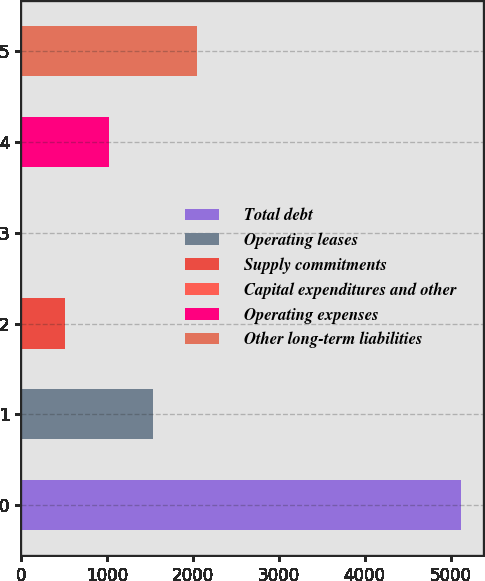Convert chart. <chart><loc_0><loc_0><loc_500><loc_500><bar_chart><fcel>Total debt<fcel>Operating leases<fcel>Supply commitments<fcel>Capital expenditures and other<fcel>Operating expenses<fcel>Other long-term liabilities<nl><fcel>5120<fcel>1536.7<fcel>512.9<fcel>1<fcel>1024.8<fcel>2048.6<nl></chart> 